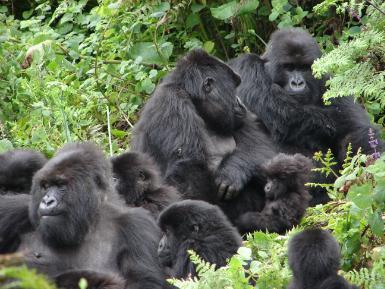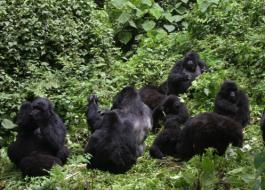The first image is the image on the left, the second image is the image on the right. Analyze the images presented: Is the assertion "There are more than two gorillas in each image." valid? Answer yes or no. Yes. The first image is the image on the left, the second image is the image on the right. Given the left and right images, does the statement "There are three black and grey adult gorillas on the ground with only baby gorilla visible." hold true? Answer yes or no. No. 